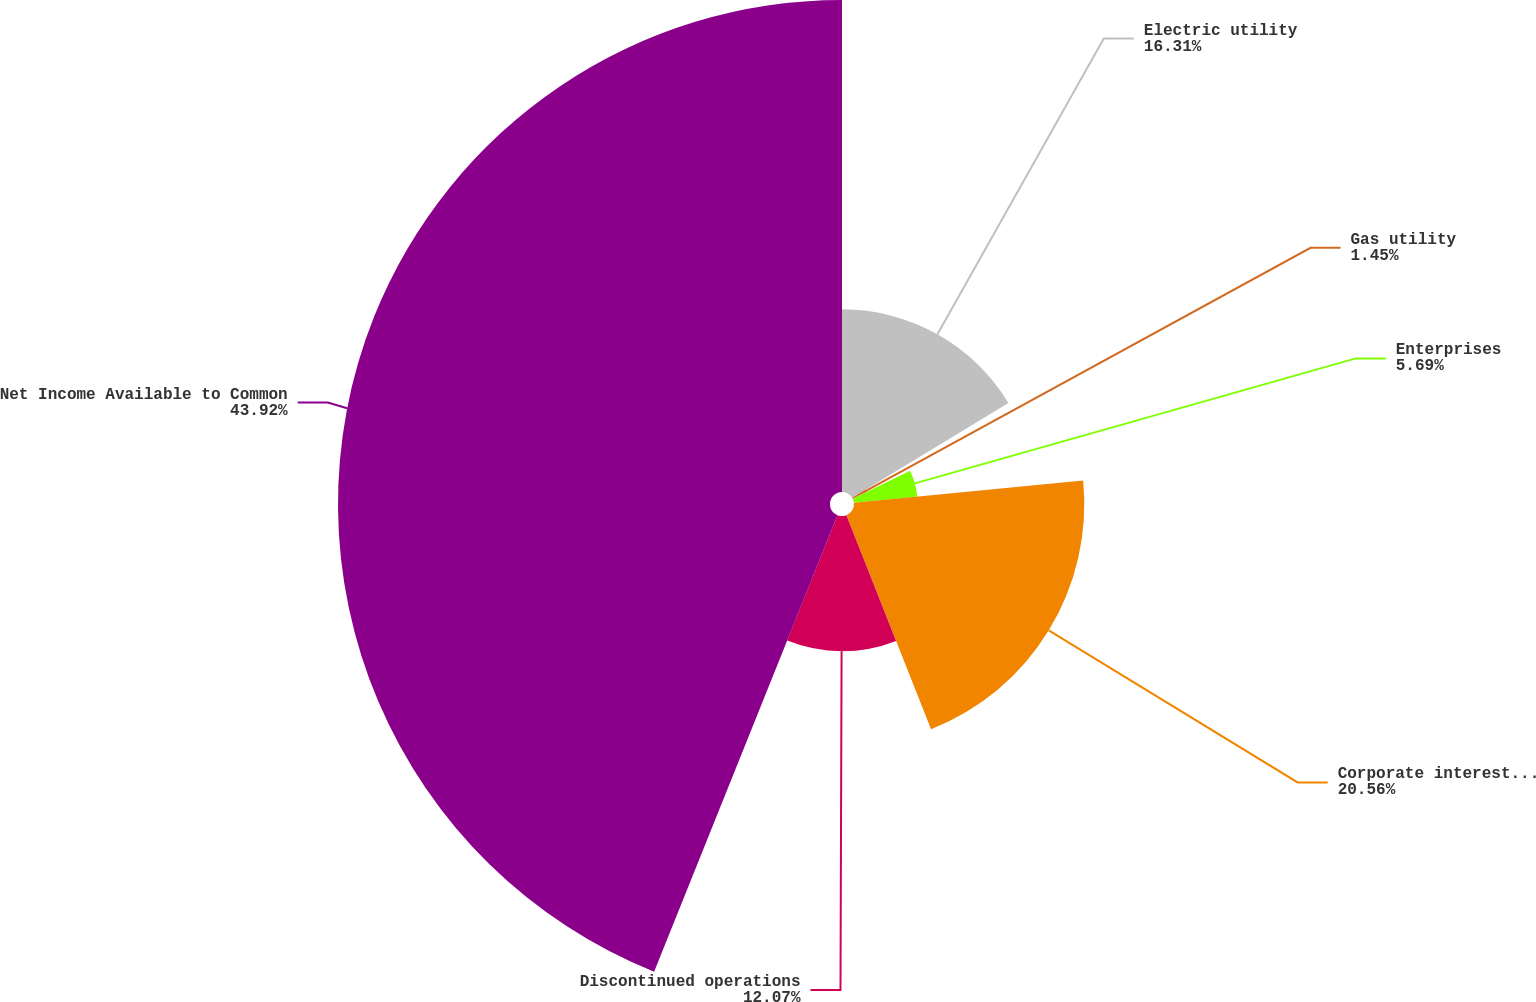<chart> <loc_0><loc_0><loc_500><loc_500><pie_chart><fcel>Electric utility<fcel>Gas utility<fcel>Enterprises<fcel>Corporate interest and other<fcel>Discontinued operations<fcel>Net Income Available to Common<nl><fcel>16.31%<fcel>1.45%<fcel>5.69%<fcel>20.56%<fcel>12.07%<fcel>43.92%<nl></chart> 